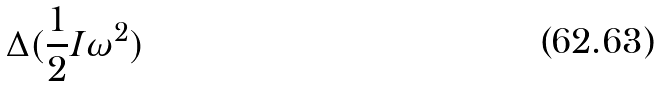Convert formula to latex. <formula><loc_0><loc_0><loc_500><loc_500>\Delta ( \frac { 1 } { 2 } I \omega ^ { 2 } )</formula> 